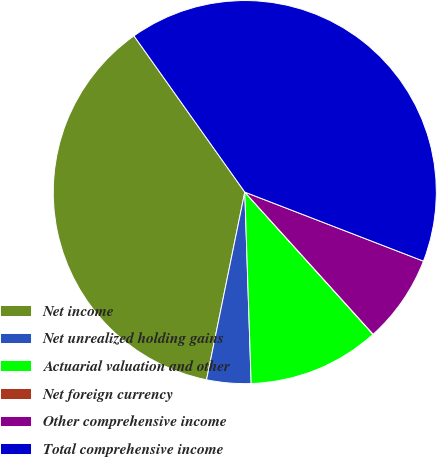Convert chart. <chart><loc_0><loc_0><loc_500><loc_500><pie_chart><fcel>Net income<fcel>Net unrealized holding gains<fcel>Actuarial valuation and other<fcel>Net foreign currency<fcel>Other comprehensive income<fcel>Total comprehensive income<nl><fcel>36.98%<fcel>3.73%<fcel>11.15%<fcel>0.01%<fcel>7.44%<fcel>40.69%<nl></chart> 